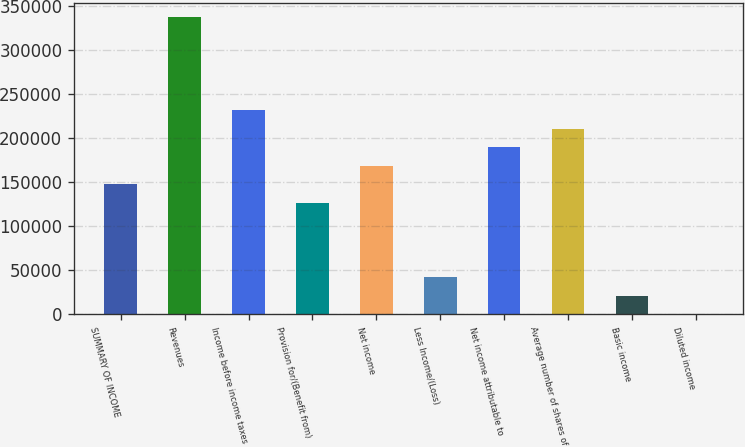Convert chart to OTSL. <chart><loc_0><loc_0><loc_500><loc_500><bar_chart><fcel>SUMMARY OF INCOME<fcel>Revenues<fcel>Income before income taxes<fcel>Provision for/(Benefit from)<fcel>Net income<fcel>Less Income/(Loss)<fcel>Net income attributable to<fcel>Average number of shares of<fcel>Basic income<fcel>Diluted income<nl><fcel>147310<fcel>336708<fcel>231487<fcel>126266<fcel>168355<fcel>42089.2<fcel>189399<fcel>210443<fcel>21045<fcel>0.8<nl></chart> 